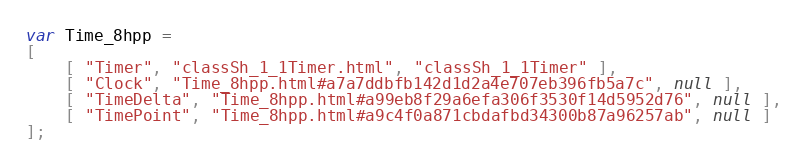Convert code to text. <code><loc_0><loc_0><loc_500><loc_500><_JavaScript_>var Time_8hpp =
[
    [ "Timer", "classSh_1_1Timer.html", "classSh_1_1Timer" ],
    [ "Clock", "Time_8hpp.html#a7a7ddbfb142d1d2a4e707eb396fb5a7c", null ],
    [ "TimeDelta", "Time_8hpp.html#a99eb8f29a6efa306f3530f14d5952d76", null ],
    [ "TimePoint", "Time_8hpp.html#a9c4f0a871cbdafbd34300b87a96257ab", null ]
];</code> 